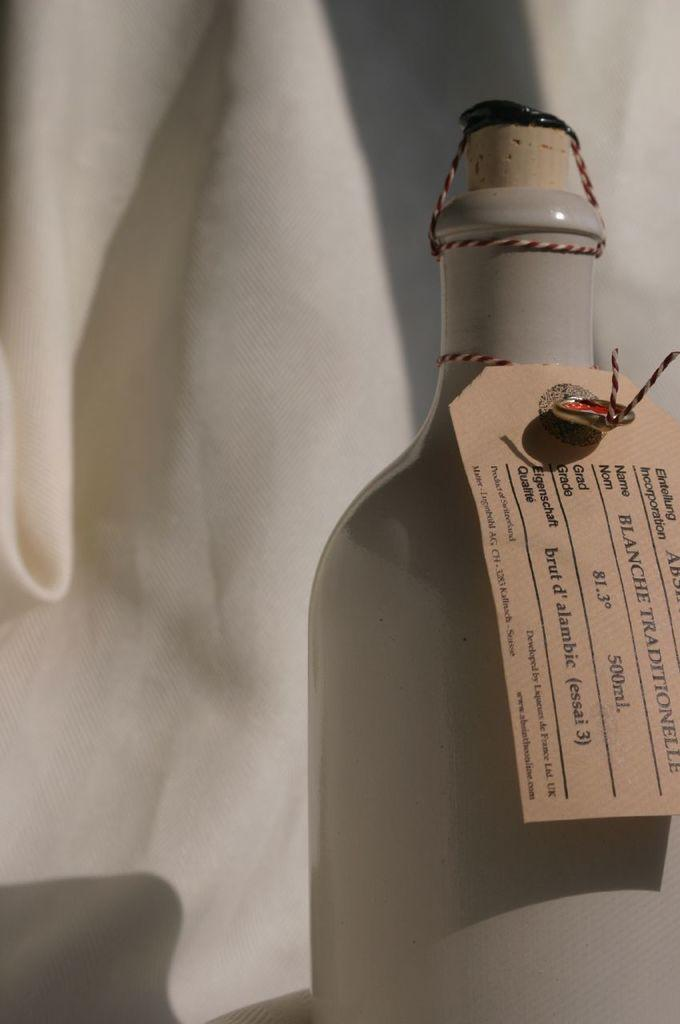<image>
Write a terse but informative summary of the picture. Bottle with a label that says Blanche Traditionelle. 